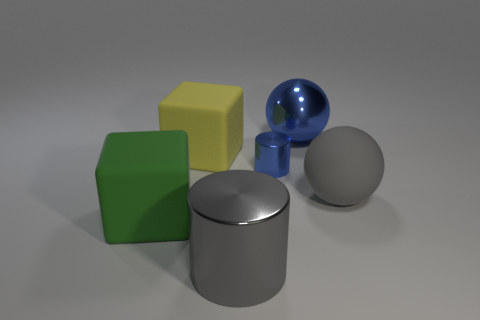Which object in this image reflects the most light? The large metallic sphere reflects the most light, indicating its highly polished surface. 